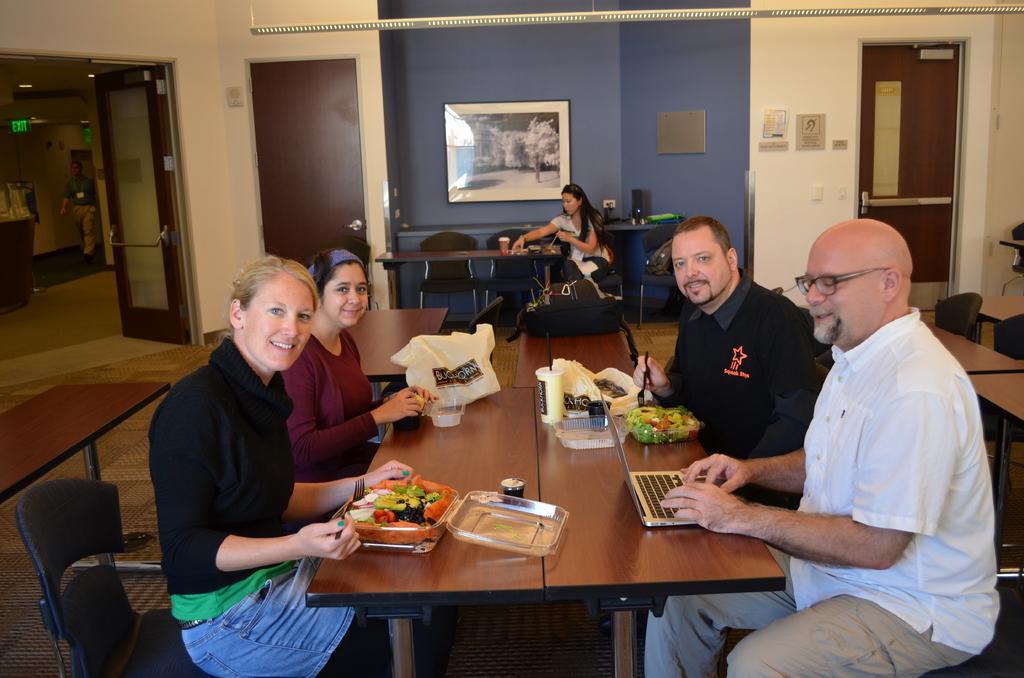Describe this image in one or two sentences. In this image there are four person sitting on a chair beside a table. On the table we can see a plastic bag, Cup, fruits, spoon and laptop. On the background we can see a painting on a blue wall. On the right there is a door. On the left is an open door. In the center we can see a woman who is holding a bag. 